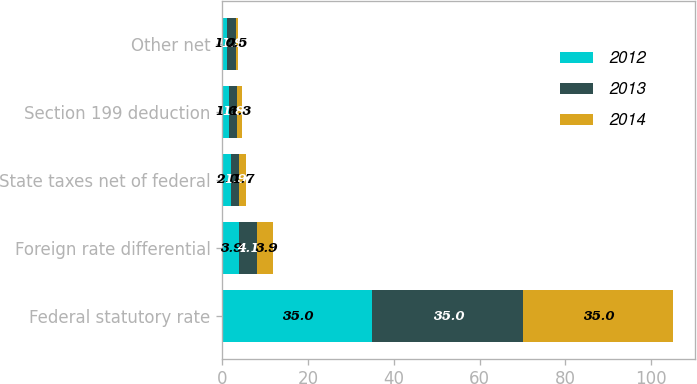Convert chart to OTSL. <chart><loc_0><loc_0><loc_500><loc_500><stacked_bar_chart><ecel><fcel>Federal statutory rate<fcel>Foreign rate differential<fcel>State taxes net of federal<fcel>Section 199 deduction<fcel>Other net<nl><fcel>2012<fcel>35<fcel>3.9<fcel>2<fcel>1.6<fcel>1.2<nl><fcel>2013<fcel>35<fcel>4.1<fcel>1.9<fcel>1.8<fcel>1.9<nl><fcel>2014<fcel>35<fcel>3.9<fcel>1.7<fcel>1.3<fcel>0.5<nl></chart> 